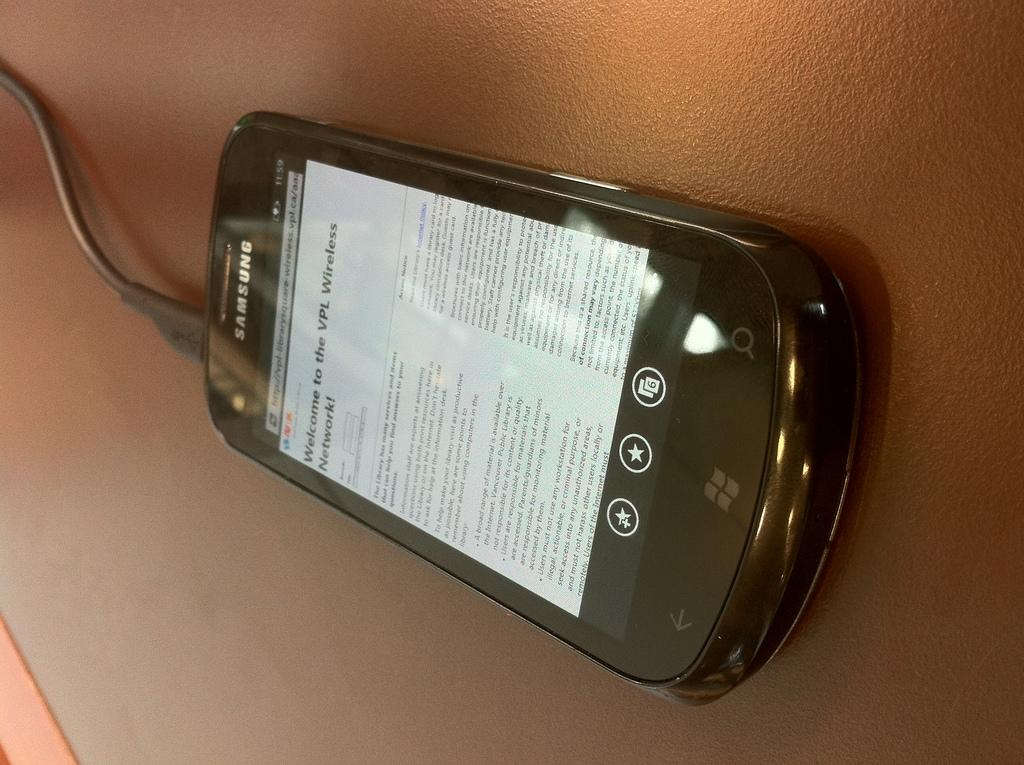<image>
Provide a brief description of the given image. a Samsung phone with a screen about a wireless network. 